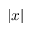<formula> <loc_0><loc_0><loc_500><loc_500>| x |</formula> 